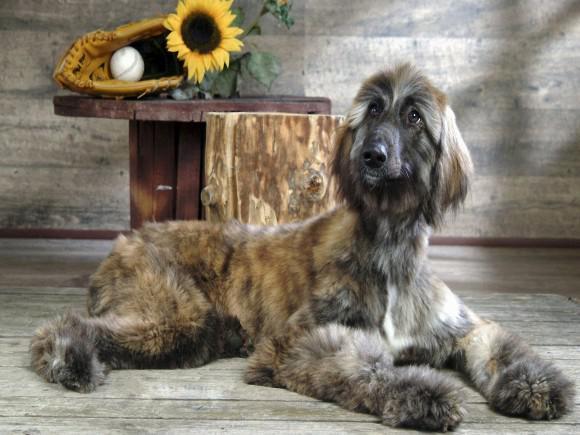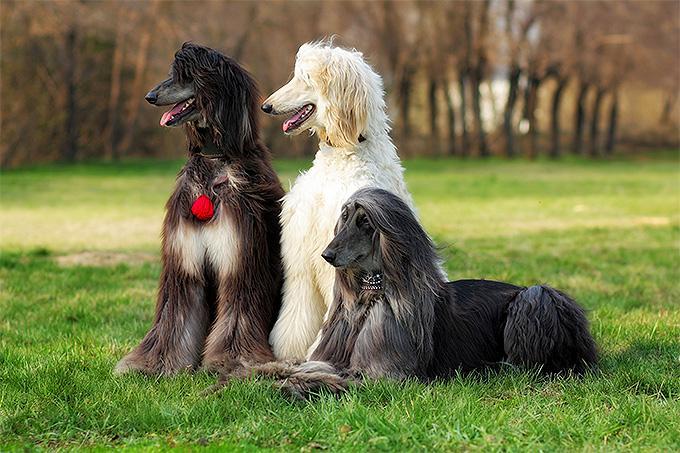The first image is the image on the left, the second image is the image on the right. Considering the images on both sides, is "An image shows a dark-haired hound lounging on furniture with throw pillows." valid? Answer yes or no. No. The first image is the image on the left, the second image is the image on the right. Examine the images to the left and right. Is the description "At least one dog in one of the images is outside on a sunny day." accurate? Answer yes or no. Yes. 